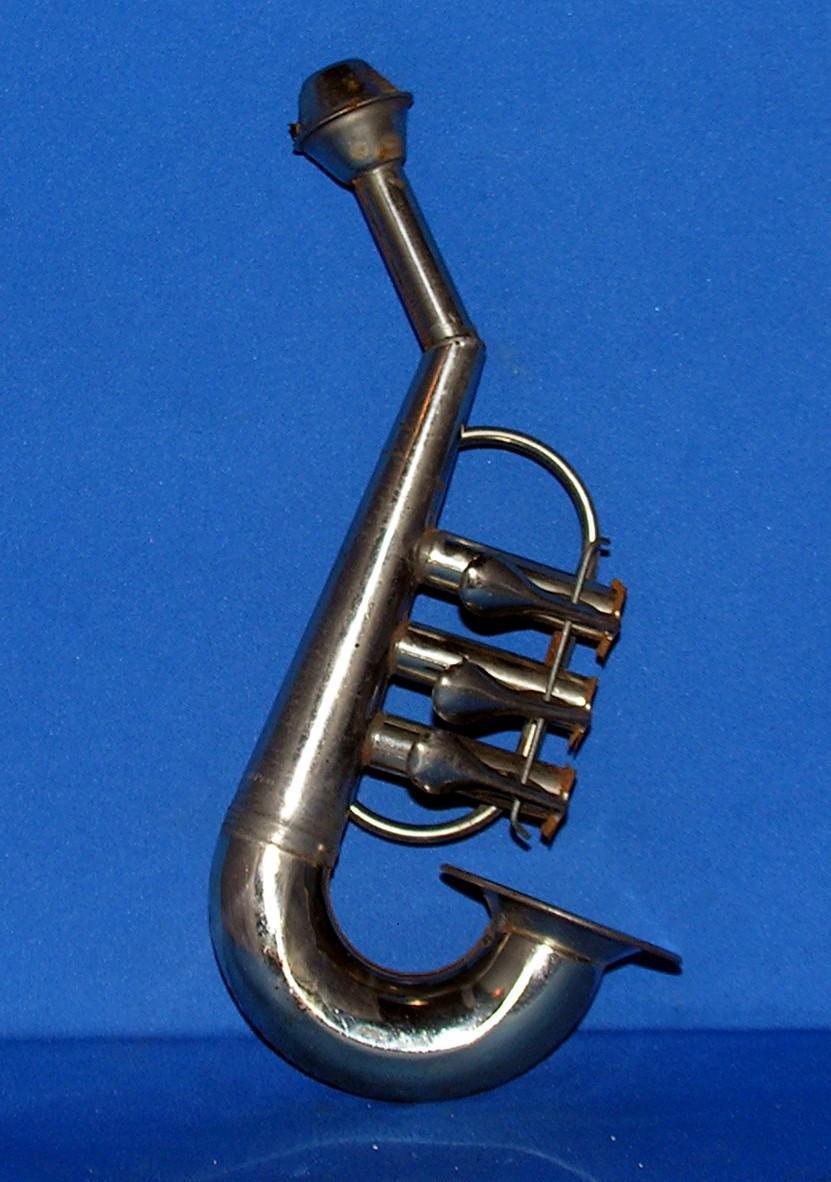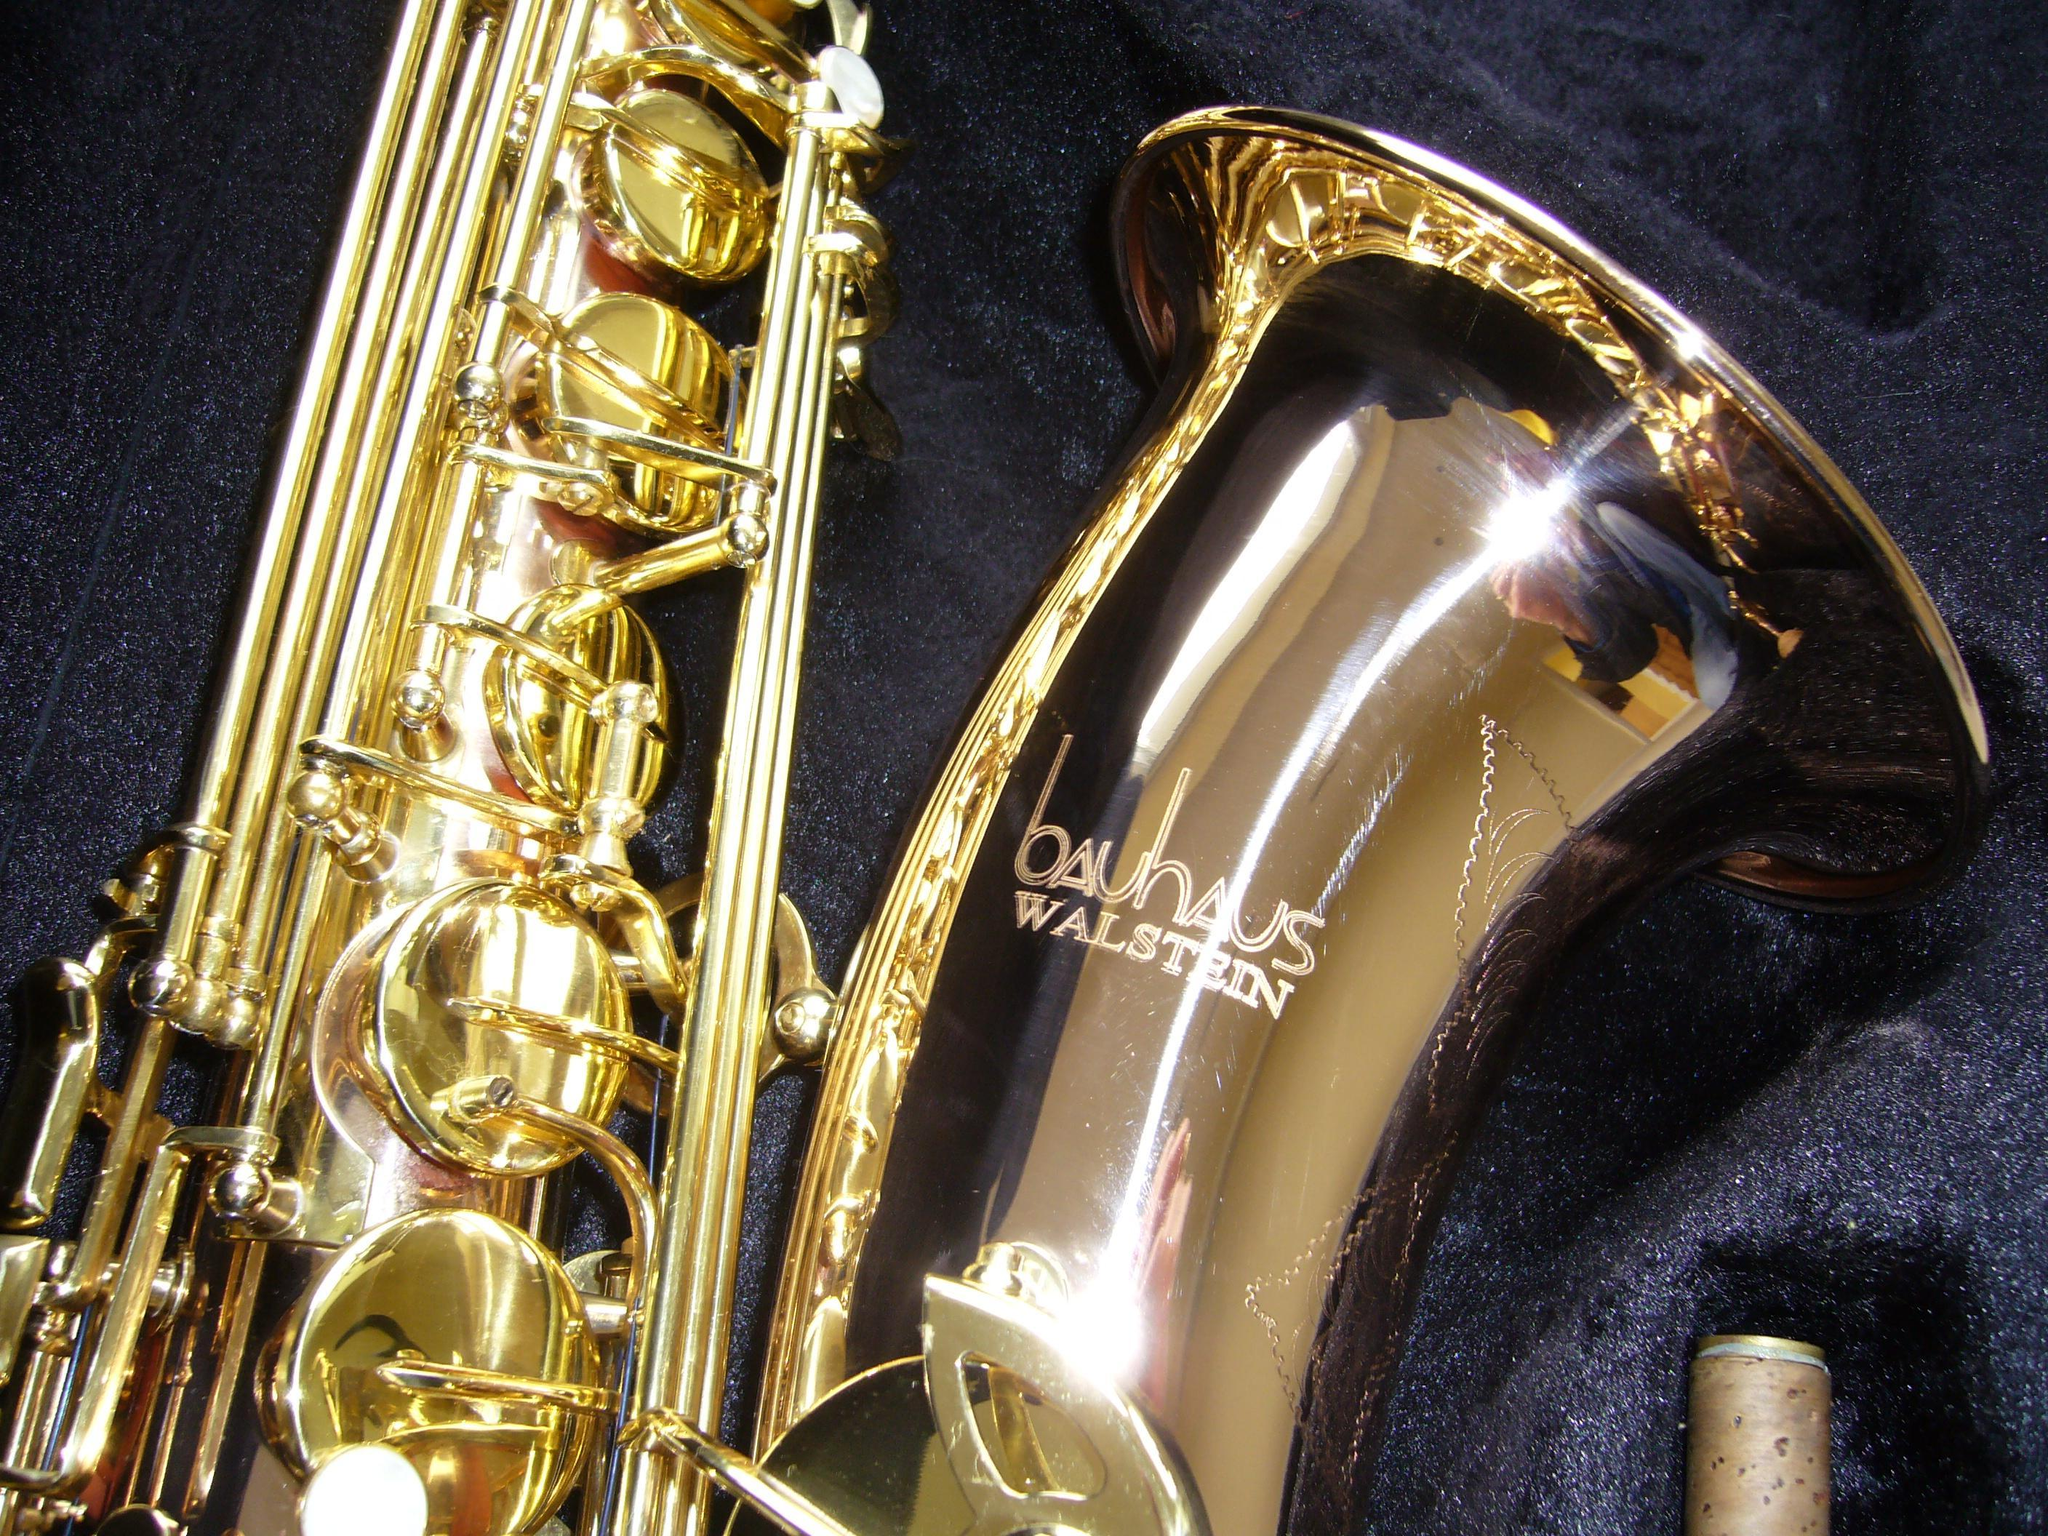The first image is the image on the left, the second image is the image on the right. Assess this claim about the two images: "One image contains a single gold saxophone with its mouthpiece at the top, and the other image shows three saxophones, at least two of them with curved bell ends.". Correct or not? Answer yes or no. No. 